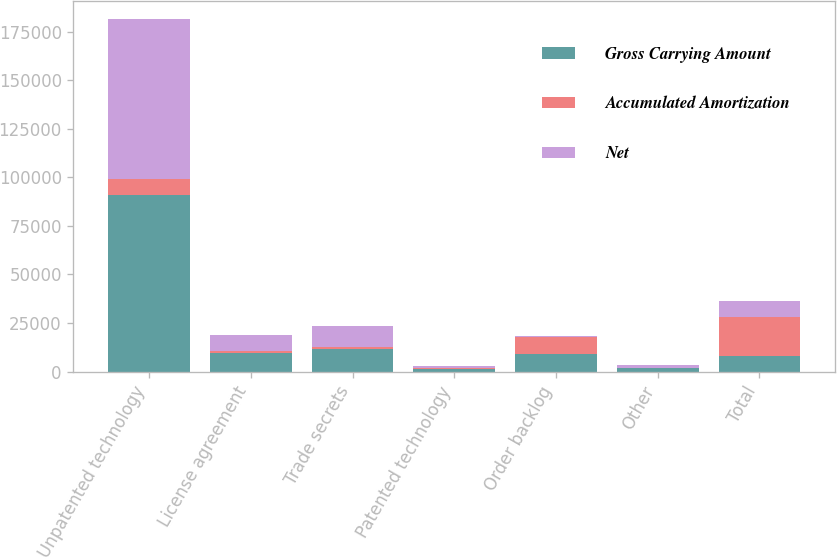<chart> <loc_0><loc_0><loc_500><loc_500><stacked_bar_chart><ecel><fcel>Unpatented technology<fcel>License agreement<fcel>Trade secrets<fcel>Patented technology<fcel>Order backlog<fcel>Other<fcel>Total<nl><fcel>Gross Carrying Amount<fcel>90786<fcel>9373<fcel>11772<fcel>1498<fcel>9245<fcel>1827<fcel>8223<nl><fcel>Accumulated Amortization<fcel>8488<fcel>1150<fcel>1159<fcel>387<fcel>8807<fcel>56<fcel>20047<nl><fcel>Net<fcel>82298<fcel>8223<fcel>10613<fcel>1111<fcel>438<fcel>1771<fcel>8223<nl></chart> 